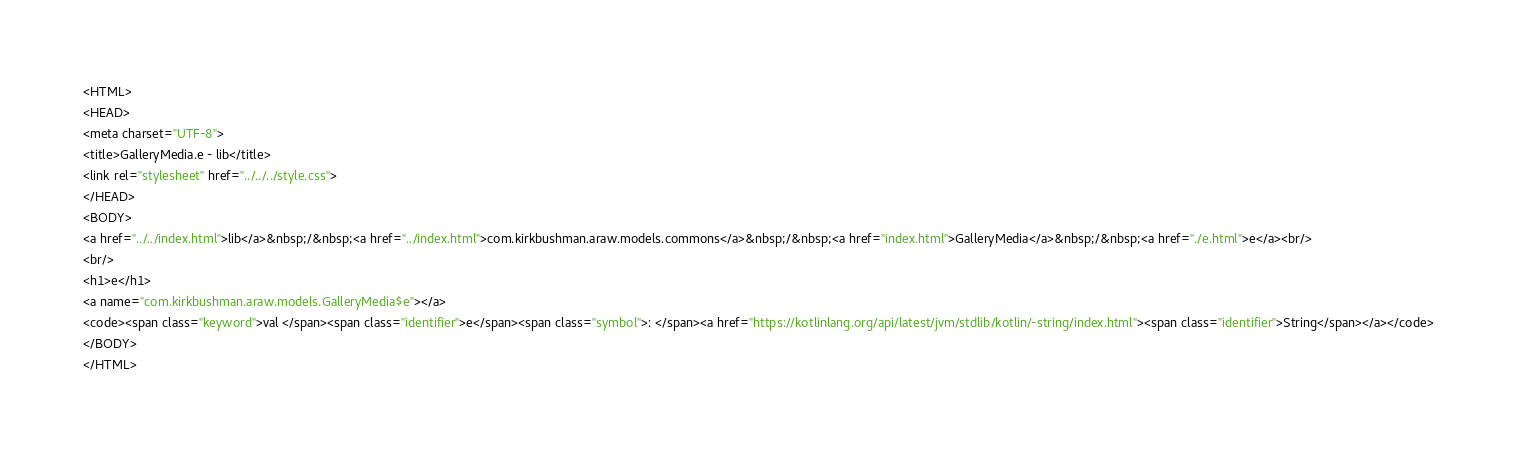Convert code to text. <code><loc_0><loc_0><loc_500><loc_500><_HTML_><HTML>
<HEAD>
<meta charset="UTF-8">
<title>GalleryMedia.e - lib</title>
<link rel="stylesheet" href="../../../style.css">
</HEAD>
<BODY>
<a href="../../index.html">lib</a>&nbsp;/&nbsp;<a href="../index.html">com.kirkbushman.araw.models.commons</a>&nbsp;/&nbsp;<a href="index.html">GalleryMedia</a>&nbsp;/&nbsp;<a href="./e.html">e</a><br/>
<br/>
<h1>e</h1>
<a name="com.kirkbushman.araw.models.GalleryMedia$e"></a>
<code><span class="keyword">val </span><span class="identifier">e</span><span class="symbol">: </span><a href="https://kotlinlang.org/api/latest/jvm/stdlib/kotlin/-string/index.html"><span class="identifier">String</span></a></code>
</BODY>
</HTML>
</code> 